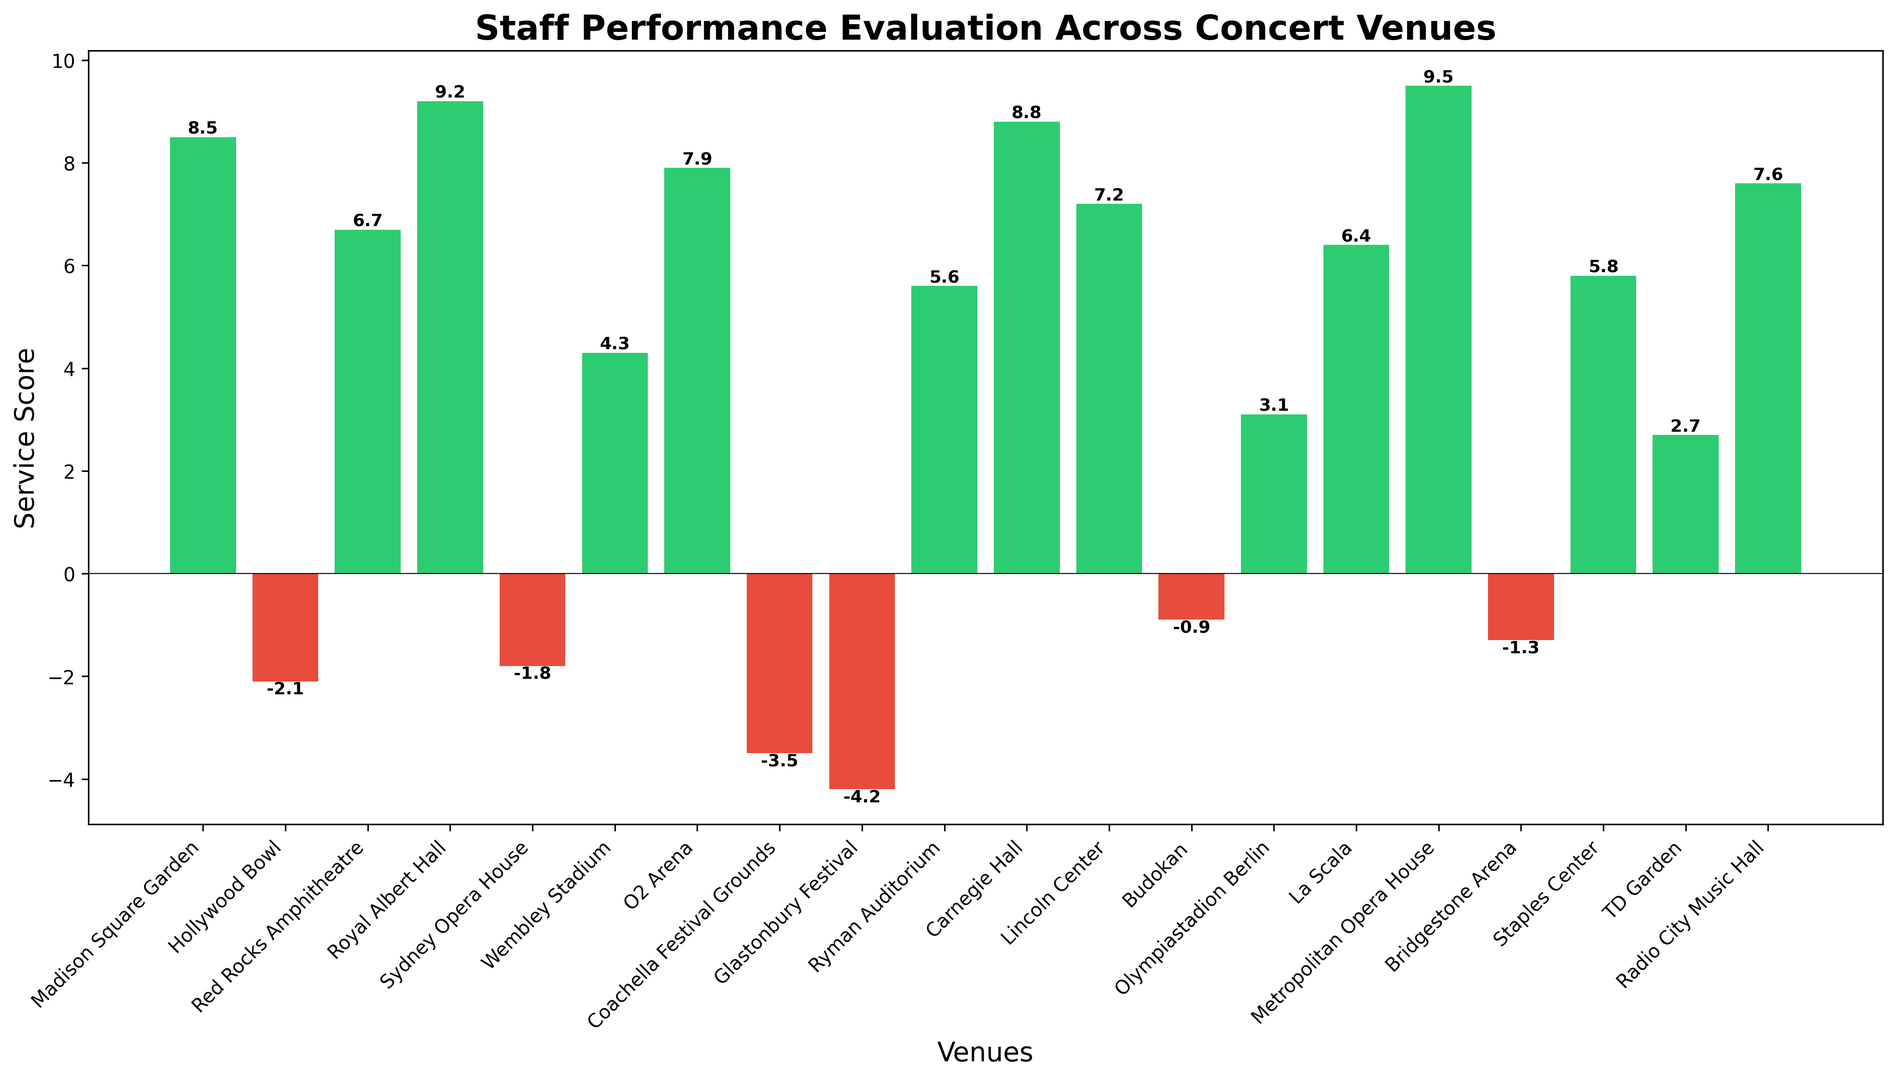What's the highest service score displayed in the figure? To find the highest service score, look for the tallest green bar. The Metropolitan Opera House has the highest score of 9.5.
Answer: 9.5 Which venue performed the worst according to the service score? To determine the worst performance, identify the lowest red bar. The venue with the lowest score is Glastonbury Festival with -4.2.
Answer: Glastonbury Festival How many venues received negative service scores? Count the red bars in the chart to determine the number of venues with negative service scores. There are six red bars representing six venues.
Answer: 6 Which venues scored above 7.0? Identify the green bars that are taller than the 7.0 mark. The venues scoring above 7.0 are Madison Square Garden, Royal Albert Hall, Carnegie Hall, O2 Arena, Lincoln Center, and Radio City Music Hall.
Answer: Madison Square Garden, Royal Albert Hall, Carnegie Hall, O2 Arena, Lincoln Center, Radio City Music Hall What is the average service score for all venues? Sum all the service scores and divide by the number of venues. (8.5 + (-2.1) + 6.7 + 9.2 + (-1.8) + 4.3 + 7.9 + (-3.5) + (-4.2) + 5.6 + 8.8 + 7.2 + (-0.9) + 3.1 + 6.4 + 9.5 + (-1.3) + 5.8 + 2.7 + 7.6) / 20 = 3.72
Answer: 3.72 Which venue's performance is closest to the average service score? Calculate the difference between each venue’s score and the average score (3.72), and find the smallest difference. Wembley Stadium's score of 4.3 is closest to the average, with a difference of 0.58.
Answer: Wembley Stadium How many venues scored between 5.0 and 8.0? Count the number of green bars with heights falling between 5.0 and 8.0. There are seven such bars.
Answer: 7 Which venues need improvement based on their service scores? Identify the red bars, which represent negative service scores, indicating areas needing improvement: Hollywood Bowl, Sydney Opera House, Coachella Festival Grounds, Glastonbury Festival, Budokan, and Bridgestone Arena.
Answer: Hollywood Bowl, Sydney Opera House, Coachella Festival Grounds, Glastonbury Festival, Budokan, Bridgestone Arena 